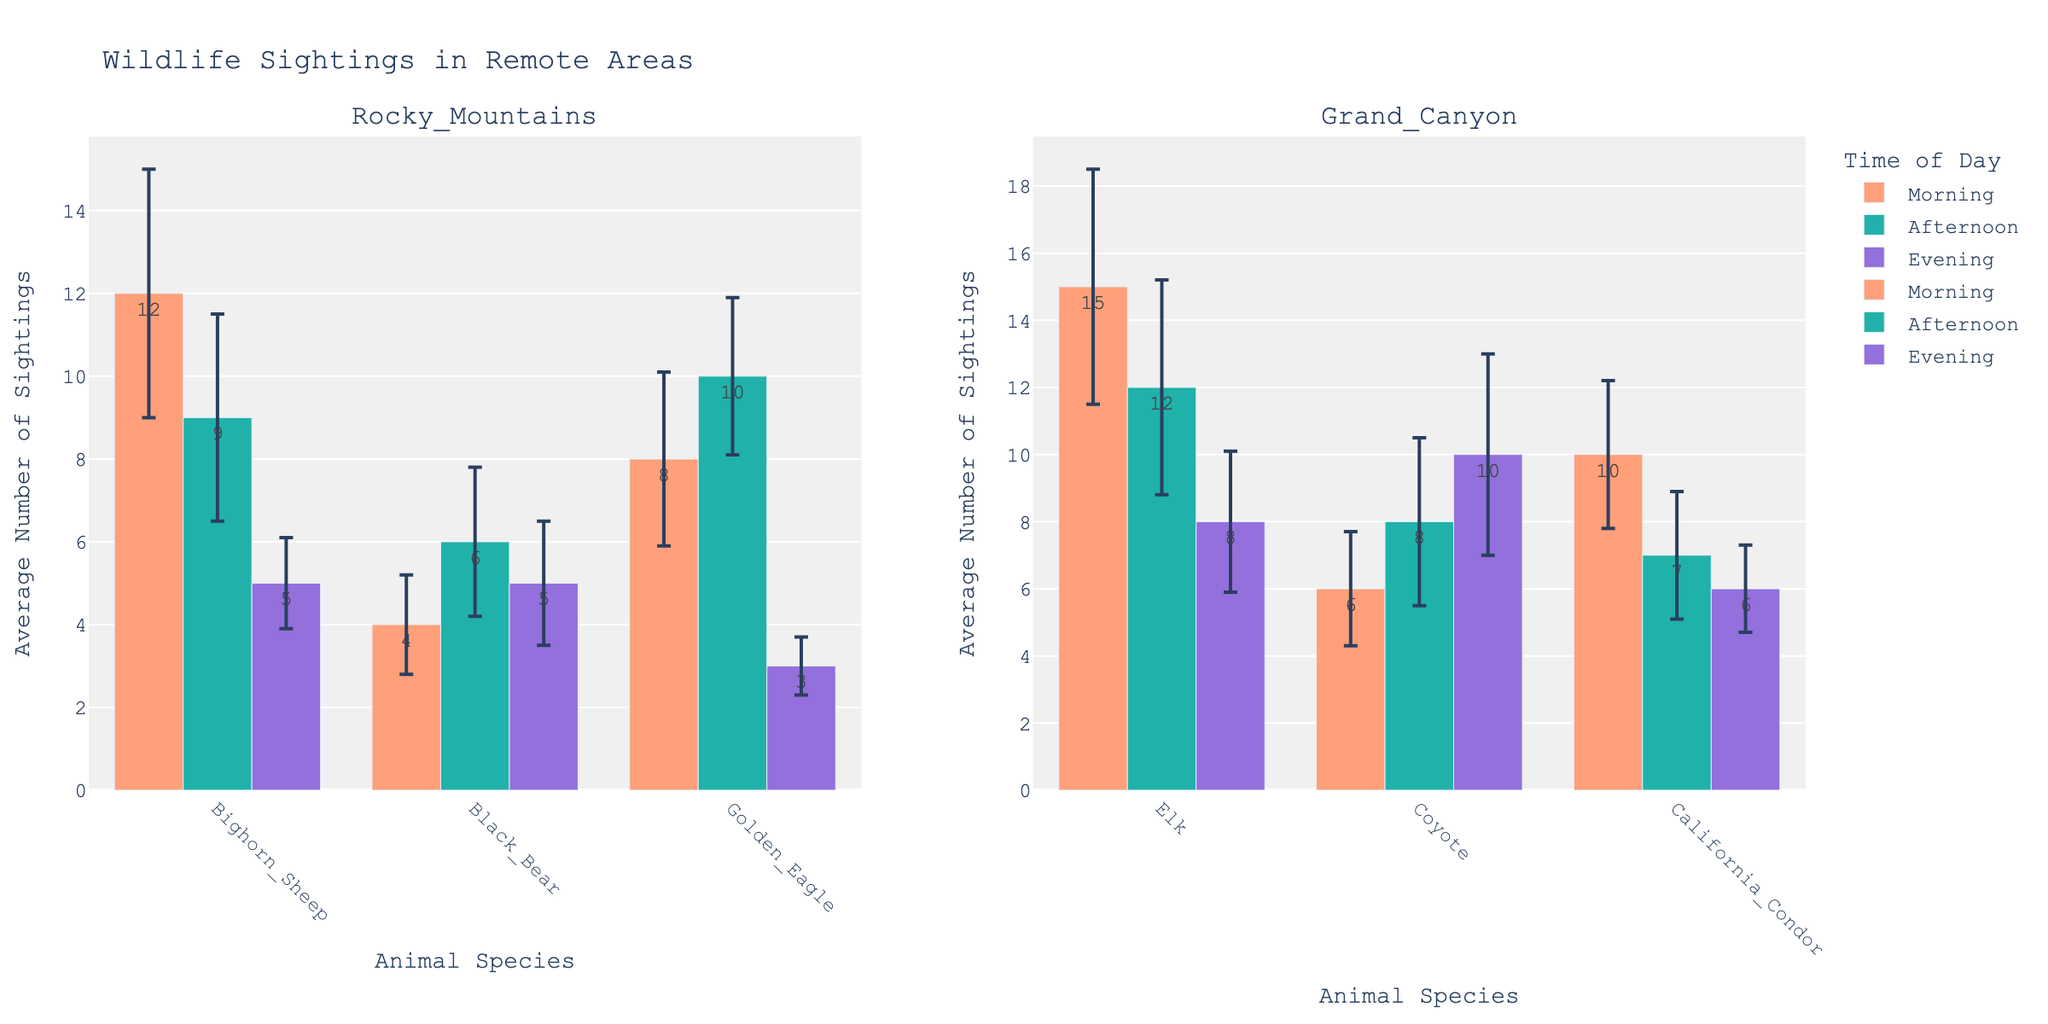How many animal sightings of Bighorn Sheep are recorded in the Rocky Mountains during the Morning? From the Rocky Mountain subplot, look for Bighorn Sheep in the Morning and find the Average Sightings bar labeled '12'.
Answer: 12 What are the animal species observed in the Grand Canyon during the Afternoon? In the Grand Canyon subplot, check for Afternoon bars and note the animals listed: Elk, Coyote, and California Condor.
Answer: Elk, Coyote, California Condor Which animal has the highest average sightings in the Grand Canyon during the Evening? For Evening Time in the Grand Canyon subplot, compare the average sighting values for each listed animal. The highest is for Coyote with a value of 10.
Answer: Coyote How do the average sightings of Black Bear in the Rocky Mountains compare between Morning and Evening? Compare the bars for Black Bear in the Rocky Mountains between Morning (4 sightings) and Evening (5 sightings); Evening sightings are slightly higher.
Answer: Evening is higher Calculate the difference in average sightings of California Condor between Morning and Afternoon in the Grand Canyon. California Condor has 10 average sightings in the Morning and 7 in the Afternoon, so the difference is 10 - 7 = 3.
Answer: 3 What is the average number of Elk sightings across all times of day in the Grand Canyon? Average the perceived sightings of Elk in the Grand Canyon for Morning (15), Afternoon (12), and Evening (8): (15 + 12 + 8) / 3 = 11.67.
Answer: 11.67 Which time of day in the Rocky Mountains has the lowest error in the average sightings for Golden Eagle? Evaluate error bars for Golden Eagle; the shortest error bar is in the Evening with a standard deviation of 0.7.
Answer: Evening Are there more total animal sightings in the Rocky Mountains in the Morning or Afternoon? Sum up all average sightings in the Rocky Mountains for Morning (12+4+8=24) and Afternoon (9+6+10=25); Afternoon has slightly more sightings.
Answer: Afternoon What is the standard deviation of Coyote sightings in the Grand Canyon during the Evening? Check the error bars for Coyote in the Grand Canyon during the Evening and find that it is labeled with 3.
Answer: 3 Explain if the average sightings for Golden Eagle are consistent across all times in the Rocky Mountains Compare the average sightings of Golden Eagle from the Rocky Mountains across Morning (8), Afternoon (10), and Evening (3). There is noticeable inconsistency, particularly low for the Evening.
Answer: Inconsistent 